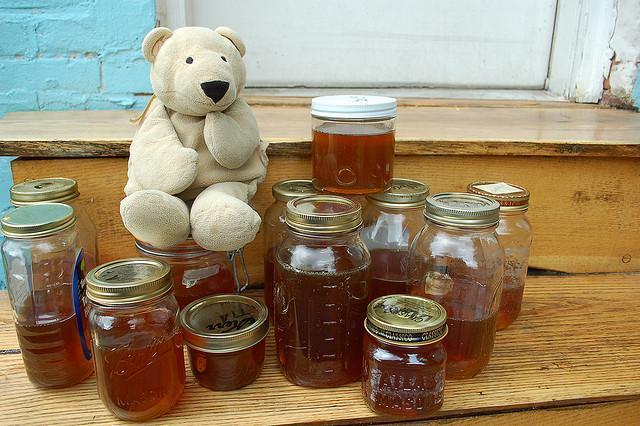How many bottles can be seen?
Give a very brief answer. 7. How many horses are in the photo?
Give a very brief answer. 0. 